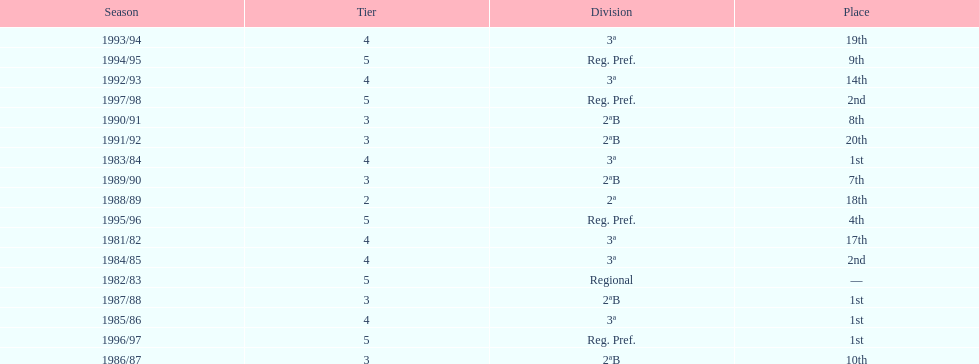How many seasons are shown in this chart? 17. 